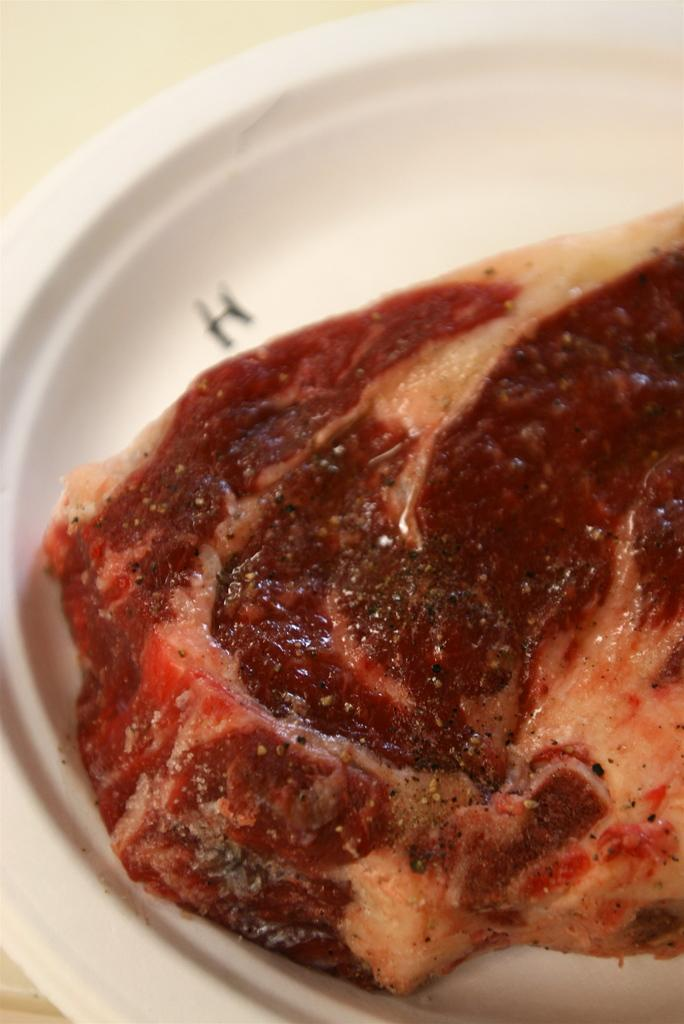What color is the plate that is visible in the image? There is a white color plate in the image. What type of food is on the plate? There is meat on the plate. What type of pencil can be seen on the plate in the image? There is no pencil present on the plate in the image; it only contains meat. 